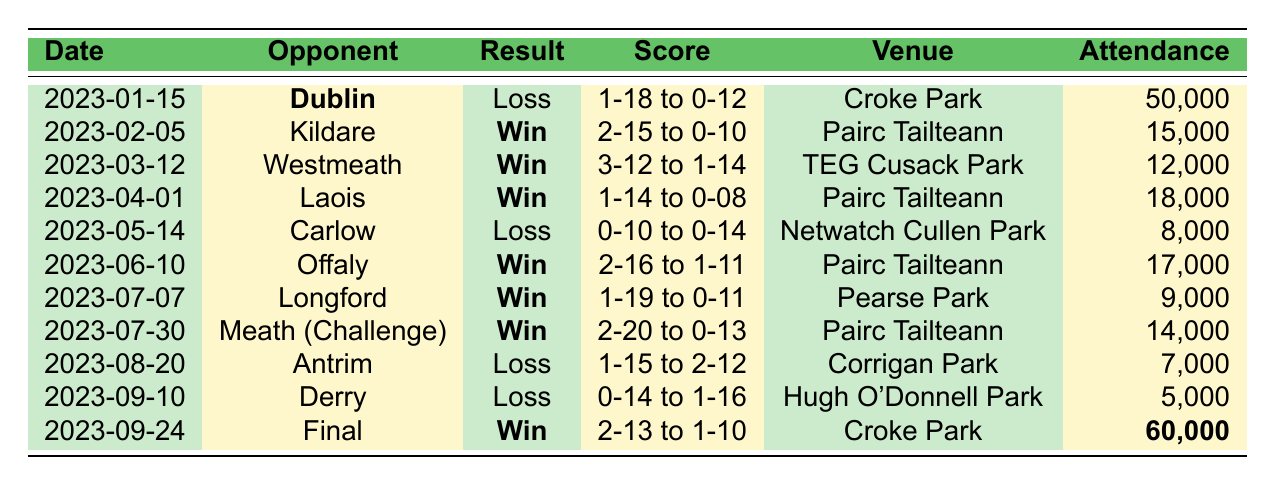What was the result of the match against Dublin on January 15, 2023? The table shows that on January 15, 2023, Meath played against Dublin and the result was a Loss.
Answer: Loss How many matches did Meath win in the 2023 season? From the table, counting the Wins only: Kildare, Westmeath, Laois, Offaly, Longford, Meath (Challenge), and Final equals 6 total wins.
Answer: 6 What was the highest attendance recorded for a Meath match in 2023? Looking at the Attendance column, the highest value is 60,000 for the Final at Croke Park.
Answer: 60,000 What was the score in Meath's match against Offaly? The table displays that against Offaly, the score was 2-16 to 1-11.
Answer: 2-16 to 1-11 How many matches did Meath lose in 2023? By reviewing the table, Meath lost matches against Dublin, Carlow, Antrim, and Derry, which totals 4 losses.
Answer: 4 What is the difference in attendance between the match against Dublin and the match against Derry? The attendance for the Dublin match was 50,000 and for the Derry match was 5,000. The difference is 50,000 - 5,000 = 45,000.
Answer: 45,000 Which opponent did Meath have the highest score against, and what was the score? The highest score was against Meath (Challenge) on July 30, 2023, with a score of 2-20 to 0-13.
Answer: Meath (Challenge), 2-20 to 0-13 What was the outcome of the match played on September 24, 2023? The table indicates that on September 24, 2023, the result was a Win in the Final against an unspecified opponent, scoring 2-13 to 1-10.
Answer: Win How many points did Meath score in their first match of the 2023 season? The table shows that in the first match against Dublin on January 15, 2023, Meath scored 0-12 points.
Answer: 12 What is the average attendance for all Meath matches in 2023? To find the average, sum the attendances: 50,000 + 15,000 + 12,000 + 18,000 + 8,000 + 17,000 + 9,000 + 14,000 + 7,000 + 5,000 + 60,000 = 300,000. There are 11 matches, so the average attendance is 300,000 / 11 = 27,272.73, approximately 27,273.
Answer: 27,273 